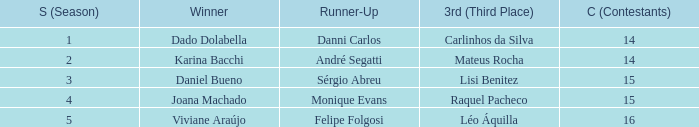In what season was the winner Dado Dolabella? 1.0. 